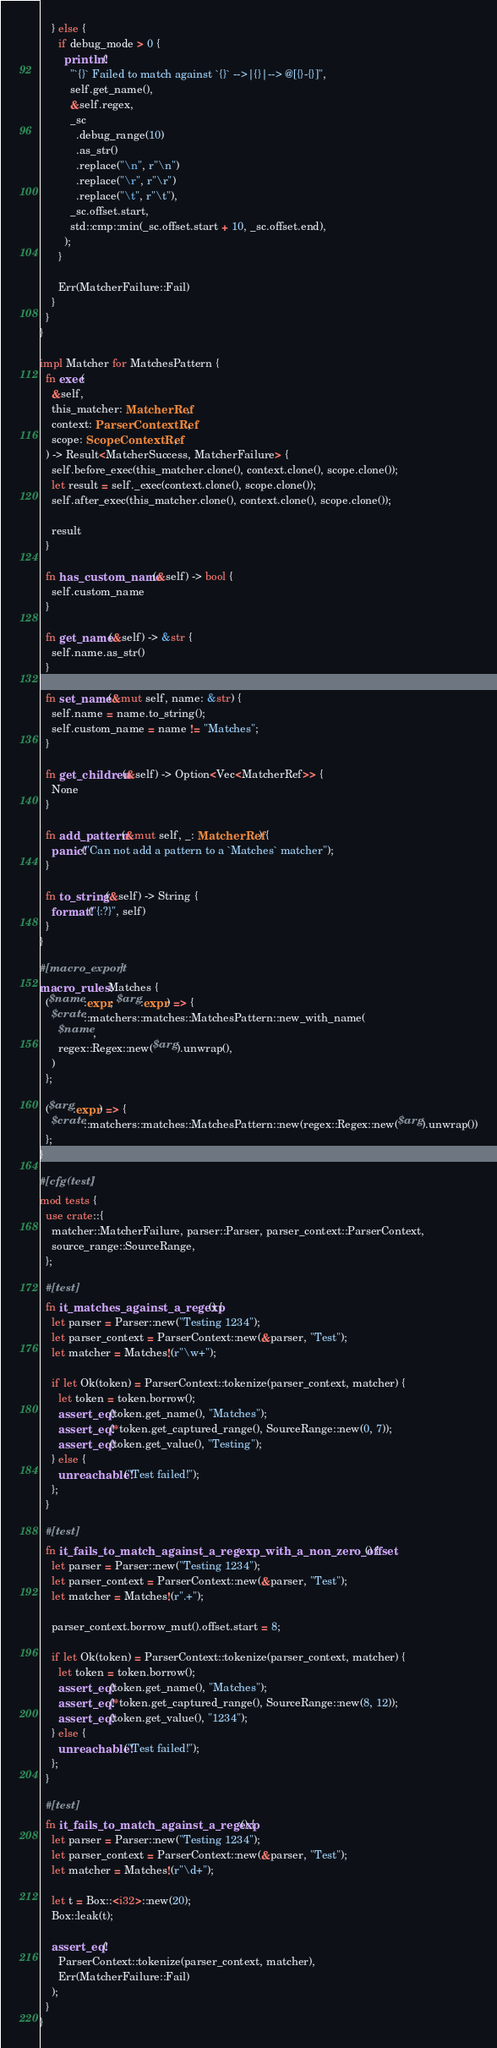Convert code to text. <code><loc_0><loc_0><loc_500><loc_500><_Rust_>    } else {
      if debug_mode > 0 {
        println!(
          "`{}` Failed to match against `{}` -->|{}|--> @[{}-{}]",
          self.get_name(),
          &self.regex,
          _sc
            .debug_range(10)
            .as_str()
            .replace("\n", r"\n")
            .replace("\r", r"\r")
            .replace("\t", r"\t"),
          _sc.offset.start,
          std::cmp::min(_sc.offset.start + 10, _sc.offset.end),
        );
      }

      Err(MatcherFailure::Fail)
    }
  }
}

impl Matcher for MatchesPattern {
  fn exec(
    &self,
    this_matcher: MatcherRef,
    context: ParserContextRef,
    scope: ScopeContextRef,
  ) -> Result<MatcherSuccess, MatcherFailure> {
    self.before_exec(this_matcher.clone(), context.clone(), scope.clone());
    let result = self._exec(context.clone(), scope.clone());
    self.after_exec(this_matcher.clone(), context.clone(), scope.clone());

    result
  }

  fn has_custom_name(&self) -> bool {
    self.custom_name
  }

  fn get_name(&self) -> &str {
    self.name.as_str()
  }

  fn set_name(&mut self, name: &str) {
    self.name = name.to_string();
    self.custom_name = name != "Matches";
  }

  fn get_children(&self) -> Option<Vec<MatcherRef>> {
    None
  }

  fn add_pattern(&mut self, _: MatcherRef) {
    panic!("Can not add a pattern to a `Matches` matcher");
  }

  fn to_string(&self) -> String {
    format!("{:?}", self)
  }
}

#[macro_export]
macro_rules! Matches {
  ($name:expr; $arg:expr) => {
    $crate::matchers::matches::MatchesPattern::new_with_name(
      $name,
      regex::Regex::new($arg).unwrap(),
    )
  };

  ($arg:expr) => {
    $crate::matchers::matches::MatchesPattern::new(regex::Regex::new($arg).unwrap())
  };
}

#[cfg(test)]
mod tests {
  use crate::{
    matcher::MatcherFailure, parser::Parser, parser_context::ParserContext,
    source_range::SourceRange,
  };

  #[test]
  fn it_matches_against_a_regexp() {
    let parser = Parser::new("Testing 1234");
    let parser_context = ParserContext::new(&parser, "Test");
    let matcher = Matches!(r"\w+");

    if let Ok(token) = ParserContext::tokenize(parser_context, matcher) {
      let token = token.borrow();
      assert_eq!(token.get_name(), "Matches");
      assert_eq!(*token.get_captured_range(), SourceRange::new(0, 7));
      assert_eq!(token.get_value(), "Testing");
    } else {
      unreachable!("Test failed!");
    };
  }

  #[test]
  fn it_fails_to_match_against_a_regexp_with_a_non_zero_offset() {
    let parser = Parser::new("Testing 1234");
    let parser_context = ParserContext::new(&parser, "Test");
    let matcher = Matches!(r".+");

    parser_context.borrow_mut().offset.start = 8;

    if let Ok(token) = ParserContext::tokenize(parser_context, matcher) {
      let token = token.borrow();
      assert_eq!(token.get_name(), "Matches");
      assert_eq!(*token.get_captured_range(), SourceRange::new(8, 12));
      assert_eq!(token.get_value(), "1234");
    } else {
      unreachable!("Test failed!");
    };
  }

  #[test]
  fn it_fails_to_match_against_a_regexp() {
    let parser = Parser::new("Testing 1234");
    let parser_context = ParserContext::new(&parser, "Test");
    let matcher = Matches!(r"\d+");

    let t = Box::<i32>::new(20);
    Box::leak(t);

    assert_eq!(
      ParserContext::tokenize(parser_context, matcher),
      Err(MatcherFailure::Fail)
    );
  }
}
</code> 